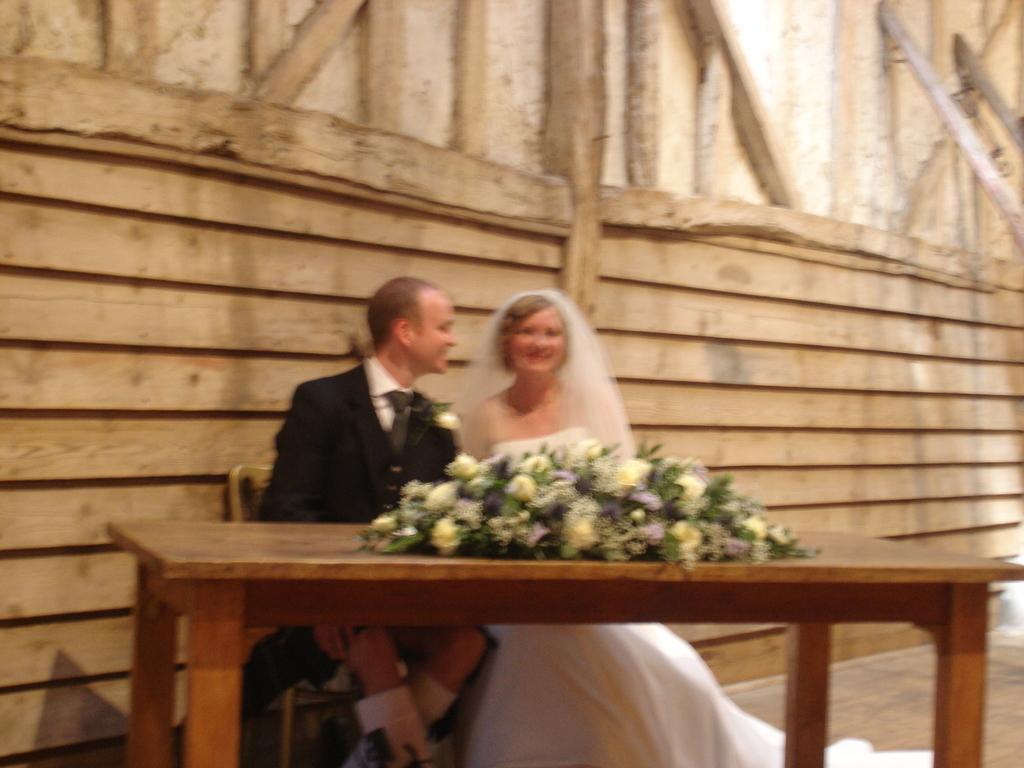Can you describe this image briefly? This picture shows couple of them seated on the chairs and a table with flowers and we see a wooden wall on the back and man wore a black color coat and women wore a white color dress and a white color cloth on the head. 